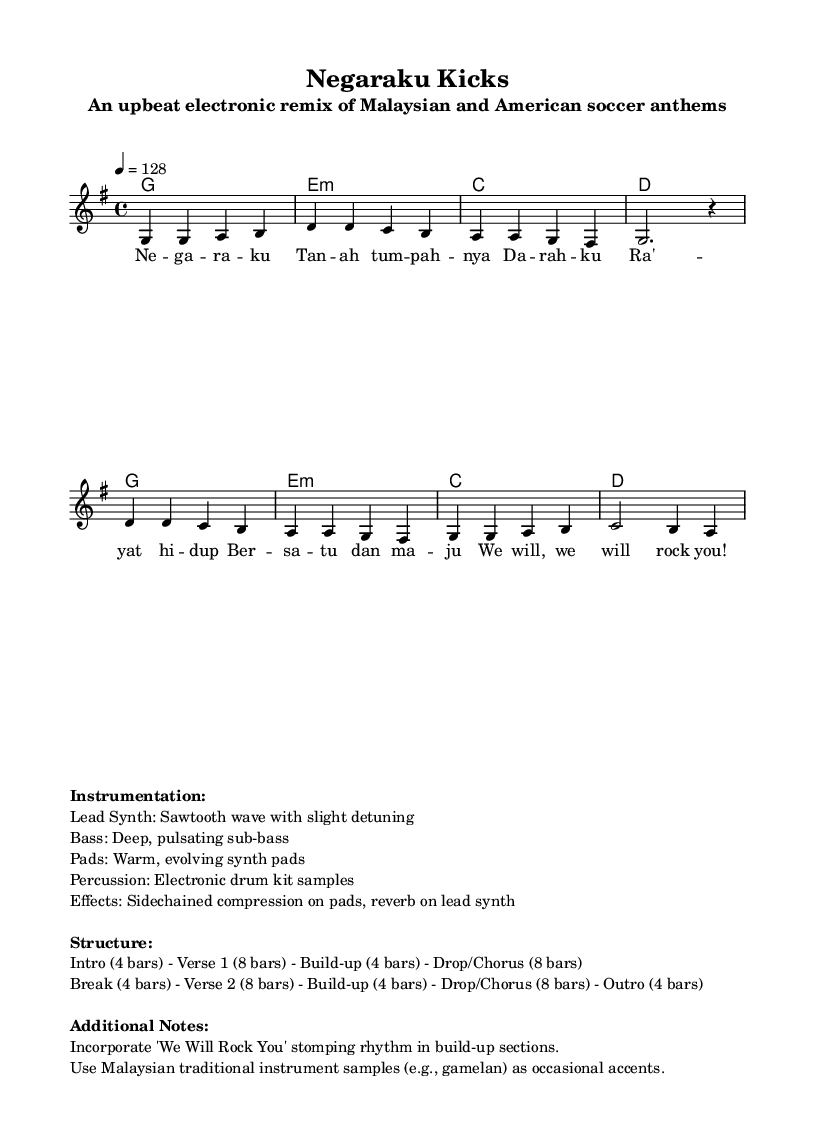What is the key signature of this music? The key signature is G major, which has one sharp (F#). This can be identified in the top left corner of the sheet music where the key signature is indicated.
Answer: G major What is the time signature of this piece? The time signature is 4/4, indicating there are four beats in each measure and the quarter note gets one beat. This is seen at the beginning of the music notation before the first measure.
Answer: 4/4 What is the tempo marking for this piece? The tempo marking is 128 beats per minute, which directs the speed of the performance. This is indicated next to the tempo instruction (4 = 128).
Answer: 128 How many bars are there in the intro section? The intro section consists of 4 bars, as specified in the structural notes provided at the bottom of the sheet music. This is derived from the descriptions following the instrumentation.
Answer: 4 What type of instrument is specified for the lead synth? The lead synth is described as using a sawtooth wave with slight detuning, noted in the instrumentation section of the sheet music. This detail provides insight into the sound design direction for the lead synth.
Answer: Sawtooth wave Which traditional instrument samples are suggested to be used? The sheet music suggests the use of gamelan samples as occasional accents, indicated in the additional notes section at the bottom. This adds an interesting flavor, combining electronic with traditional sounds.
Answer: Gamelan 